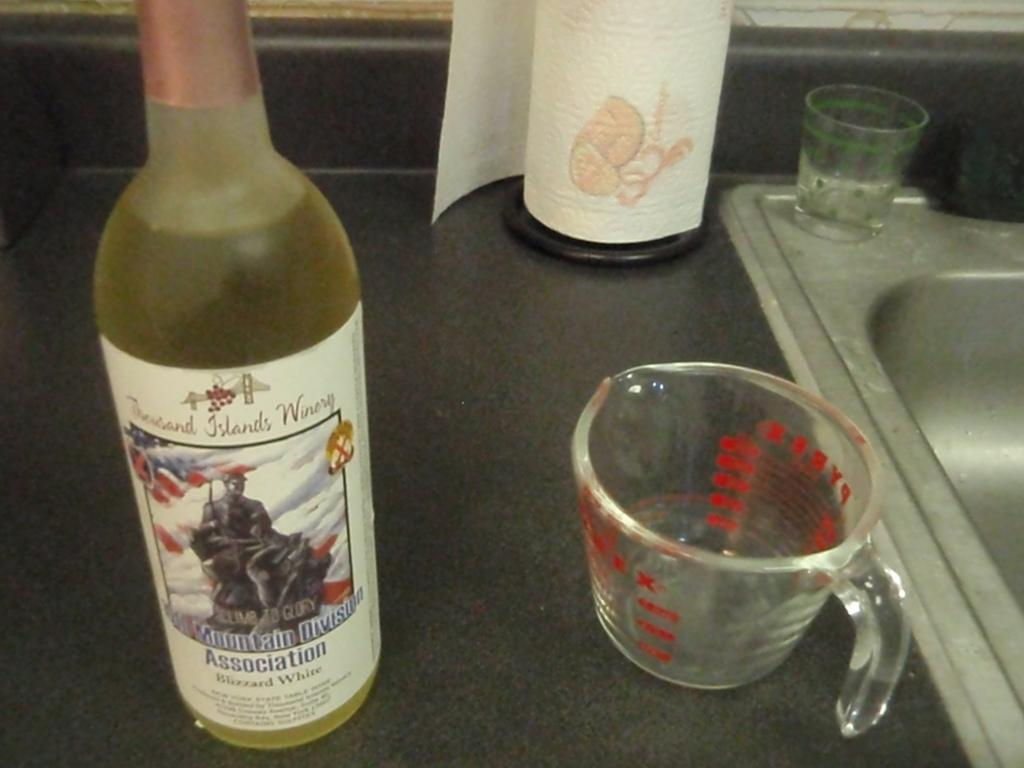What object is present in the image that can hold a liquid? There is a bottle in the image that can hold a liquid. What is depicted on the bottle? The bottle has a sticker of a man on it. What can be seen behind the bottle? There is a glass behind the bottle. What is a feature of the room visible in the image? There is a sink in the image. What is an item on the floor in the image? There is a tissue paper on the floor. What type of brass instrument can be seen in the image? There is no brass instrument present in the image. What mountain range is visible in the background of the image? There is no mountain range visible in the image. 